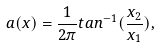Convert formula to latex. <formula><loc_0><loc_0><loc_500><loc_500>a ( x ) = \frac { 1 } { 2 \pi } t a n ^ { - 1 } ( \frac { x _ { 2 } } { x _ { 1 } } ) ,</formula> 